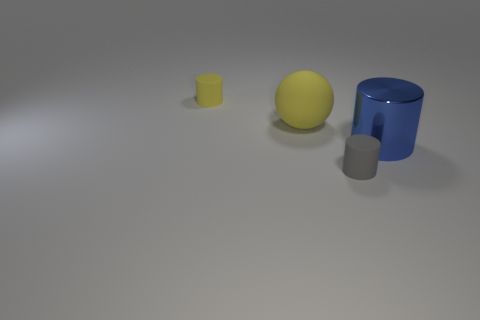Subtract all gray rubber cylinders. How many cylinders are left? 2 Add 3 large objects. How many objects exist? 7 Subtract all red cylinders. Subtract all blue balls. How many cylinders are left? 3 Subtract all spheres. How many objects are left? 3 Subtract all tiny brown matte cylinders. Subtract all matte balls. How many objects are left? 3 Add 2 cylinders. How many cylinders are left? 5 Add 1 blue things. How many blue things exist? 2 Subtract 0 blue spheres. How many objects are left? 4 